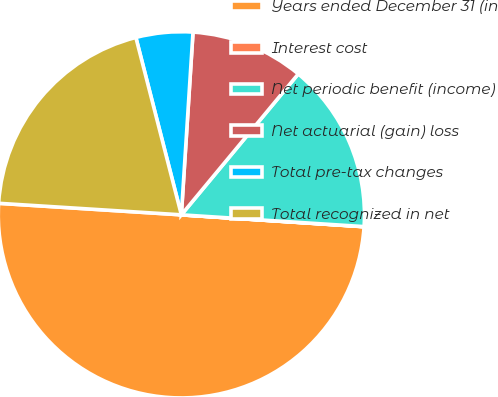<chart> <loc_0><loc_0><loc_500><loc_500><pie_chart><fcel>Years ended December 31 (in<fcel>Interest cost<fcel>Net periodic benefit (income)<fcel>Net actuarial (gain) loss<fcel>Total pre-tax changes<fcel>Total recognized in net<nl><fcel>49.97%<fcel>0.01%<fcel>15.0%<fcel>10.01%<fcel>5.01%<fcel>20.0%<nl></chart> 